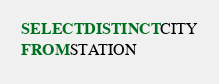Convert code to text. <code><loc_0><loc_0><loc_500><loc_500><_SQL_>SELECT DISTINCT CITY
FROM STATION</code> 